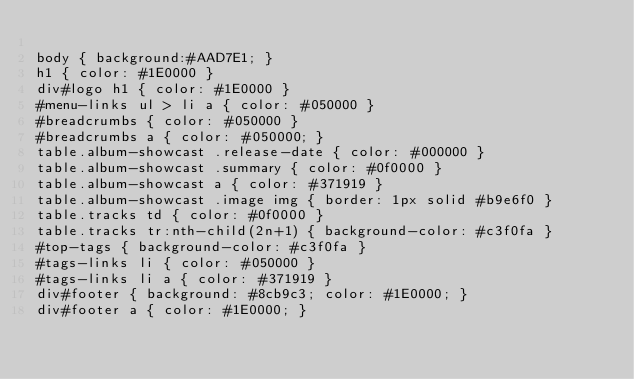Convert code to text. <code><loc_0><loc_0><loc_500><loc_500><_CSS_>
body { background:#AAD7E1; }
h1 { color: #1E0000 }
div#logo h1 { color: #1E0000 }
#menu-links ul > li a { color: #050000 }
#breadcrumbs { color: #050000 }
#breadcrumbs a { color: #050000; }
table.album-showcast .release-date { color: #000000 }
table.album-showcast .summary { color: #0f0000 }
table.album-showcast a { color: #371919 }
table.album-showcast .image img { border: 1px solid #b9e6f0 }
table.tracks td { color: #0f0000 }
table.tracks tr:nth-child(2n+1) { background-color: #c3f0fa }
#top-tags { background-color: #c3f0fa }
#tags-links li { color: #050000 }
#tags-links li a { color: #371919 }
div#footer { background: #8cb9c3; color: #1E0000; }
div#footer a { color: #1E0000; }
</code> 